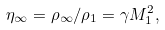<formula> <loc_0><loc_0><loc_500><loc_500>\eta _ { \infty } = \rho _ { \infty } / \rho _ { 1 } = \gamma M _ { 1 } ^ { 2 } ,</formula> 